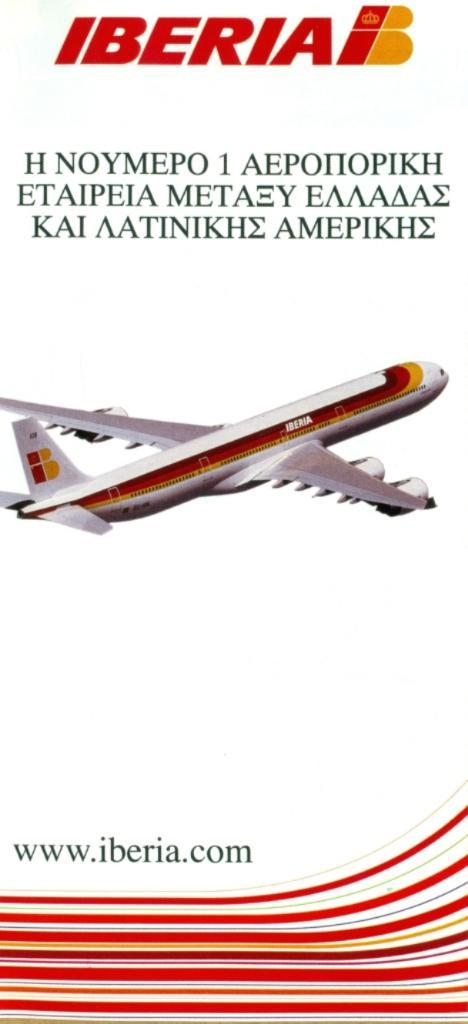Provide a one-sentence caption for the provided image. Plane that is located in iberia with a brochure of the plane. 